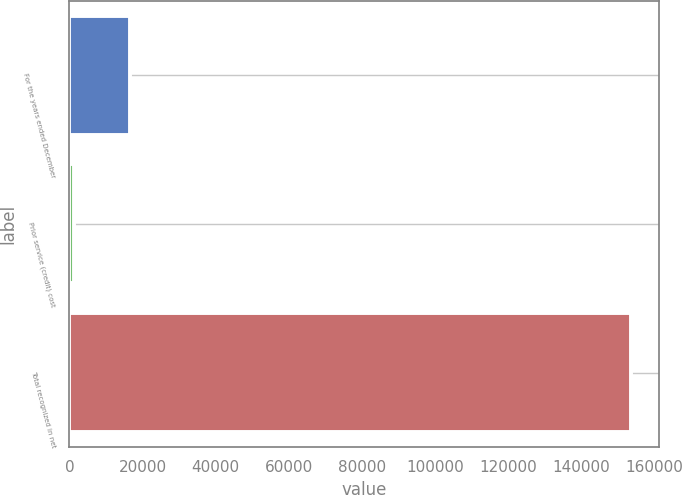Convert chart to OTSL. <chart><loc_0><loc_0><loc_500><loc_500><bar_chart><fcel>For the years ended December<fcel>Prior service (credit) cost<fcel>Total recognized in net<nl><fcel>16542.2<fcel>1313<fcel>153605<nl></chart> 